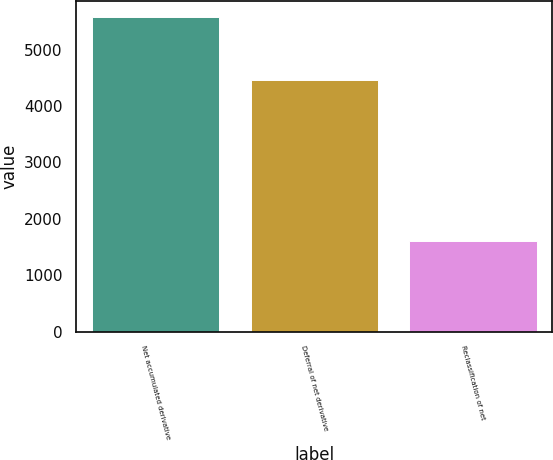Convert chart. <chart><loc_0><loc_0><loc_500><loc_500><bar_chart><fcel>Net accumulated derivative<fcel>Deferral of net derivative<fcel>Reclassification of net<nl><fcel>5576<fcel>4452<fcel>1599<nl></chart> 